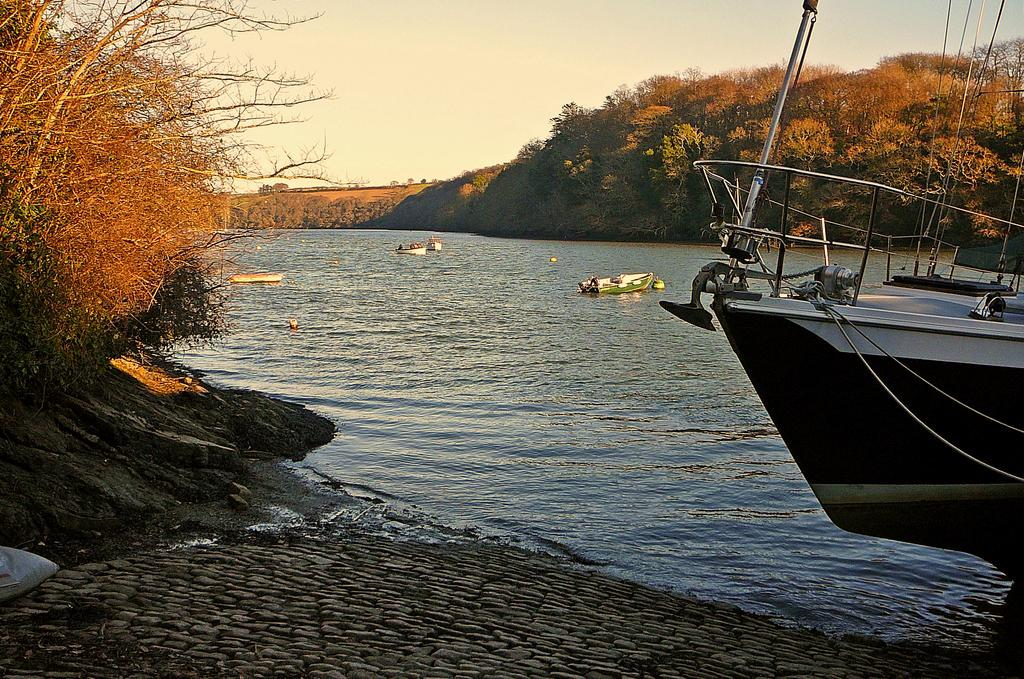What type of natural elements can be seen in the image? There are trees and plants in the image. What man-made objects are visible in the image? There are boats in the image. What body of water is present in the image? There is a river in the middle of the image. What is visible at the top of the image? The sky is visible at the top of the image. How many hands are holding the ant in the image? There are no hands or ants present in the image. What type of game is being played in the image? There is no game being played in the image; it features trees, plants, boats, a river, and the sky. 